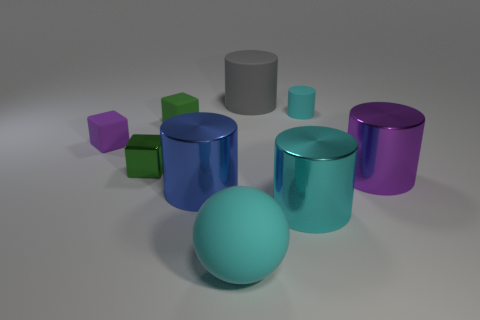What number of other objects are there of the same color as the shiny cube?
Offer a terse response. 1. What size is the blue object?
Provide a succinct answer. Large. Is there a green metal cylinder?
Offer a very short reply. No. Is the number of cyan shiny cylinders that are in front of the blue cylinder greater than the number of tiny purple things that are behind the small cyan thing?
Provide a succinct answer. Yes. The large cylinder that is to the right of the big gray thing and on the left side of the purple metal thing is made of what material?
Your response must be concise. Metal. Is the purple metal thing the same shape as the gray rubber thing?
Your answer should be compact. Yes. How many shiny cylinders are right of the big matte sphere?
Your answer should be very brief. 2. There is a blue thing in front of the green matte cube; does it have the same size as the purple block?
Provide a succinct answer. No. What color is the other matte object that is the same shape as the gray matte thing?
Provide a short and direct response. Cyan. Is there anything else that is the same shape as the big cyan matte thing?
Keep it short and to the point. No. 